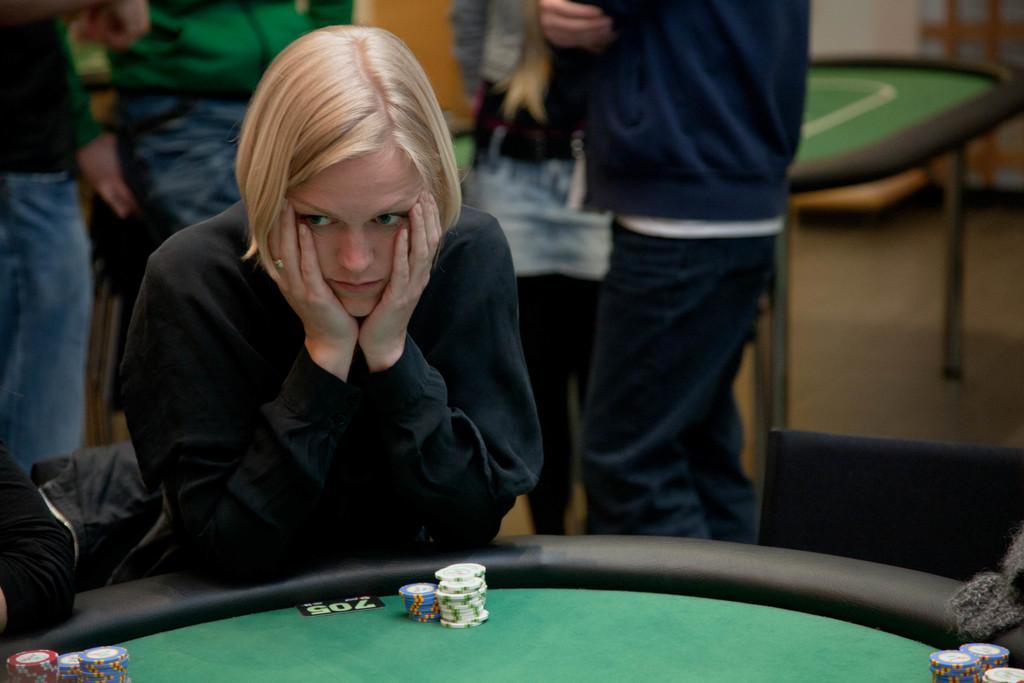How would you summarize this image in a sentence or two? This picture shows a woman seated and playing poker on the table and we see few people standing on the back 